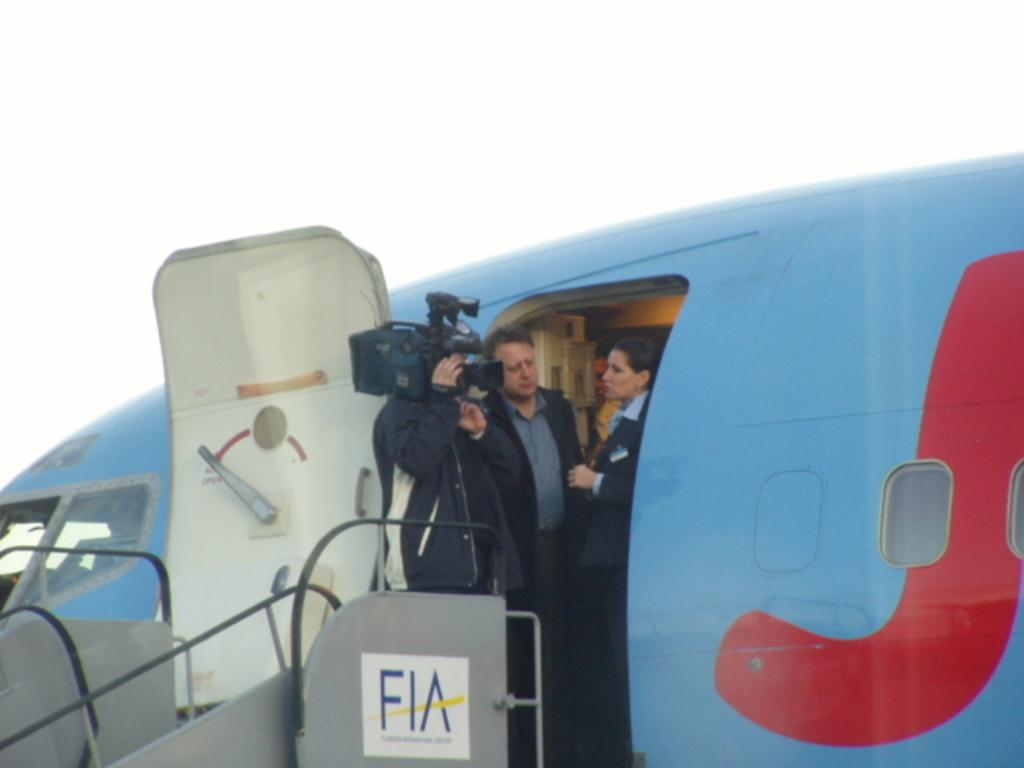Provide a one-sentence caption for the provided image. A woan getting off a Fia plane with a camera in her face. 